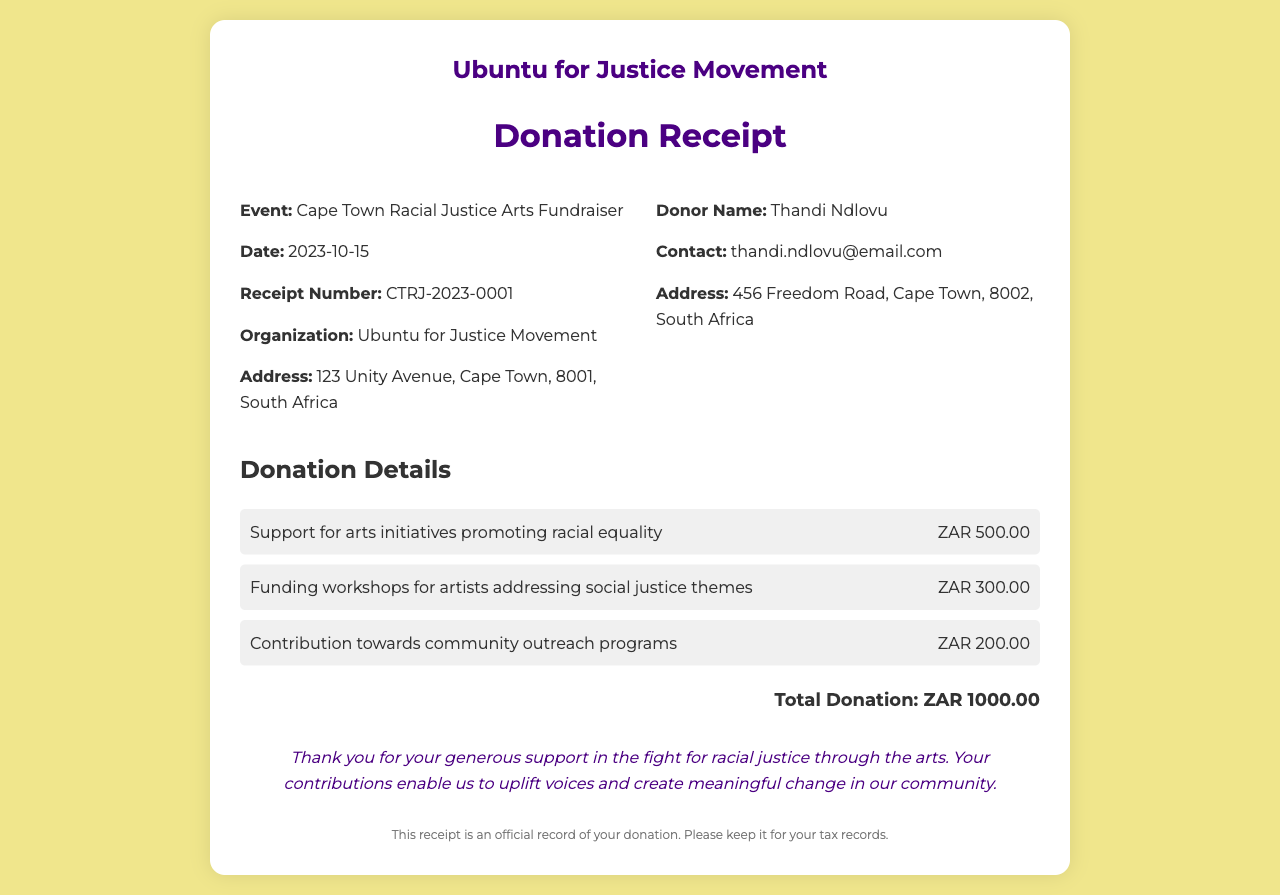What is the event name? The event name is clearly stated in the document as part of the receipt details.
Answer: Cape Town Racial Justice Arts Fundraiser What is the total donation amount? The total donation amount is calculated and displayed at the bottom of the donation details section.
Answer: ZAR 1000.00 Who is the donor? The donor's name is specified in the receipt details section.
Answer: Thandi Ndlovu What date was the event held? The date of the event is explicitly noted in the receipt details section.
Answer: 2023-10-15 What is the purpose of the first donation item mentioned? The purpose of the first donation item gives insight into the specific use of funds as detailed in the donation items section.
Answer: Support for arts initiatives promoting racial equality How many donation items are listed? The total number of donation items mentioned can be counted from the document.
Answer: 3 What is the address of the organization? The organization’s address is provided in the receipt details section for identification purposes.
Answer: 123 Unity Avenue, Cape Town, 8001, South Africa Why is this document important for the donor? The significance of the document is indicated in the footer.
Answer: For tax records What is included in the thank-you message? The thank-you message expresses gratitude and outlines the impact of the contributions.
Answer: Your contributions enable us to uplift voices and create meaningful change in our community 